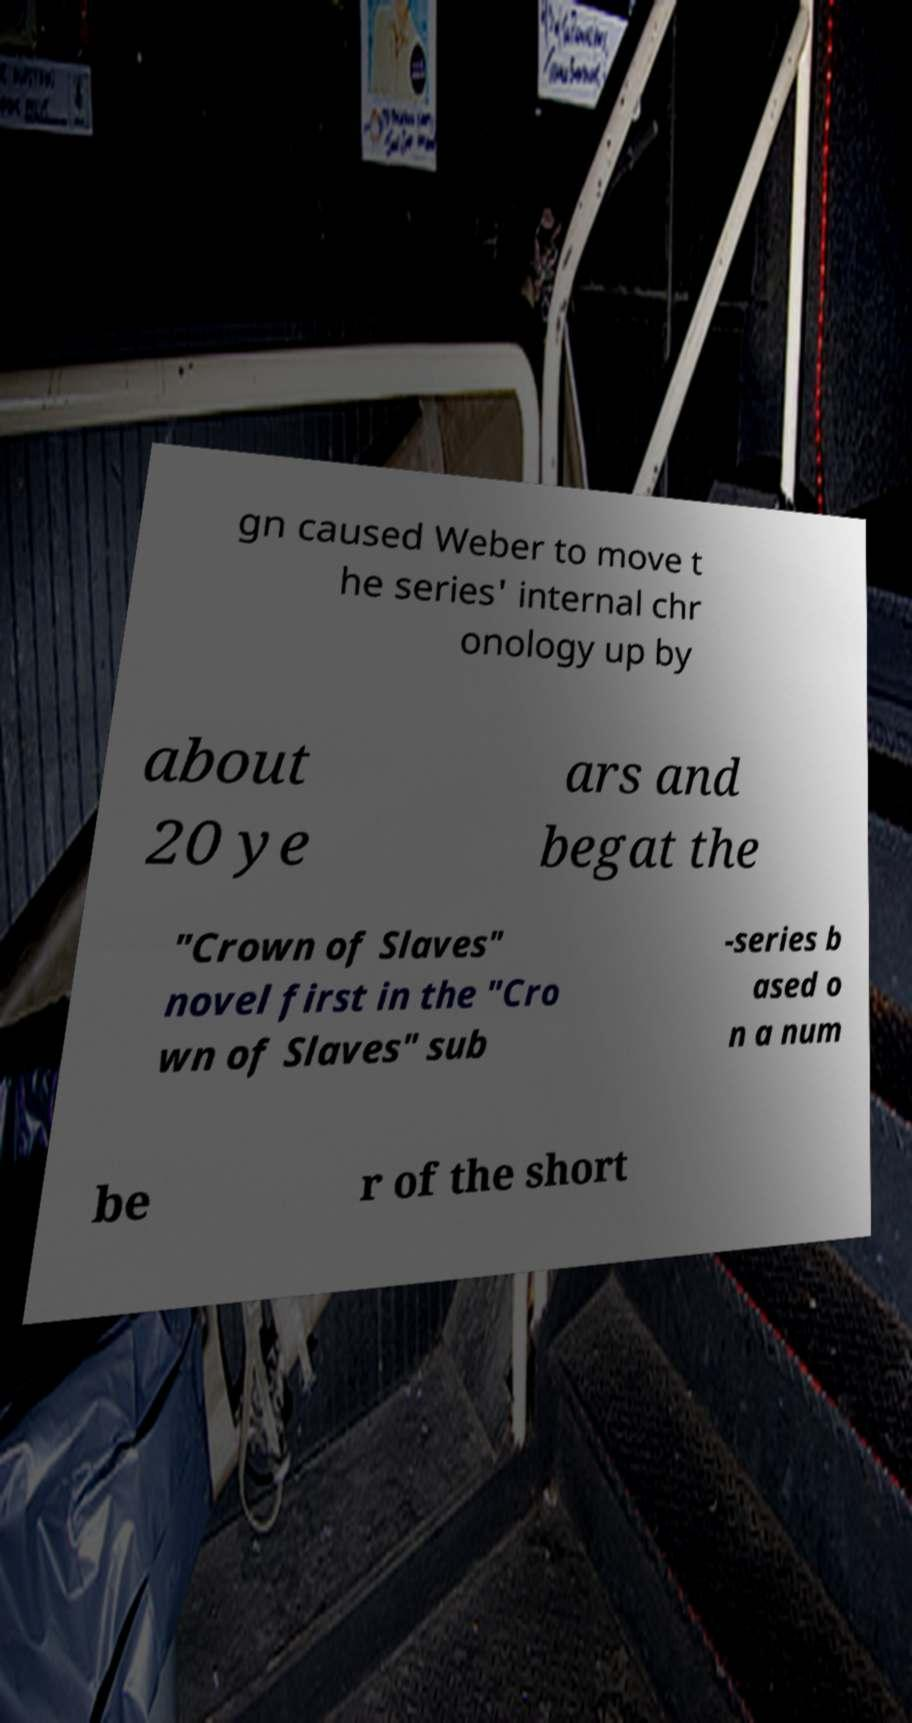Can you accurately transcribe the text from the provided image for me? gn caused Weber to move t he series' internal chr onology up by about 20 ye ars and begat the "Crown of Slaves" novel first in the "Cro wn of Slaves" sub -series b ased o n a num be r of the short 